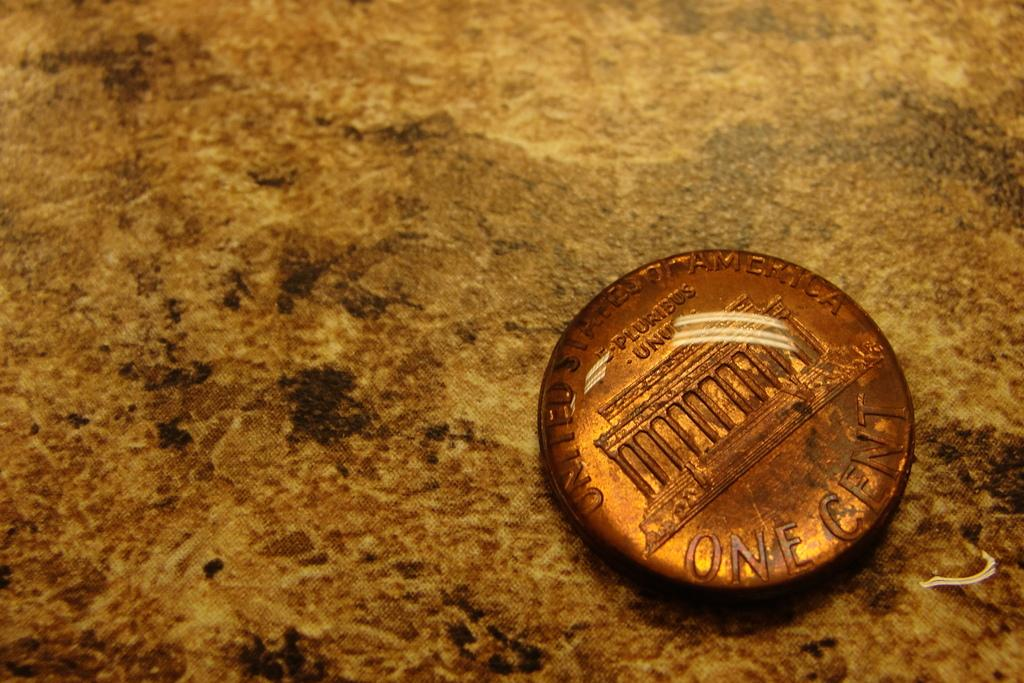Provide a one-sentence caption for the provided image. the back of a UNITED STATES OF AMERICA one cent penny. 